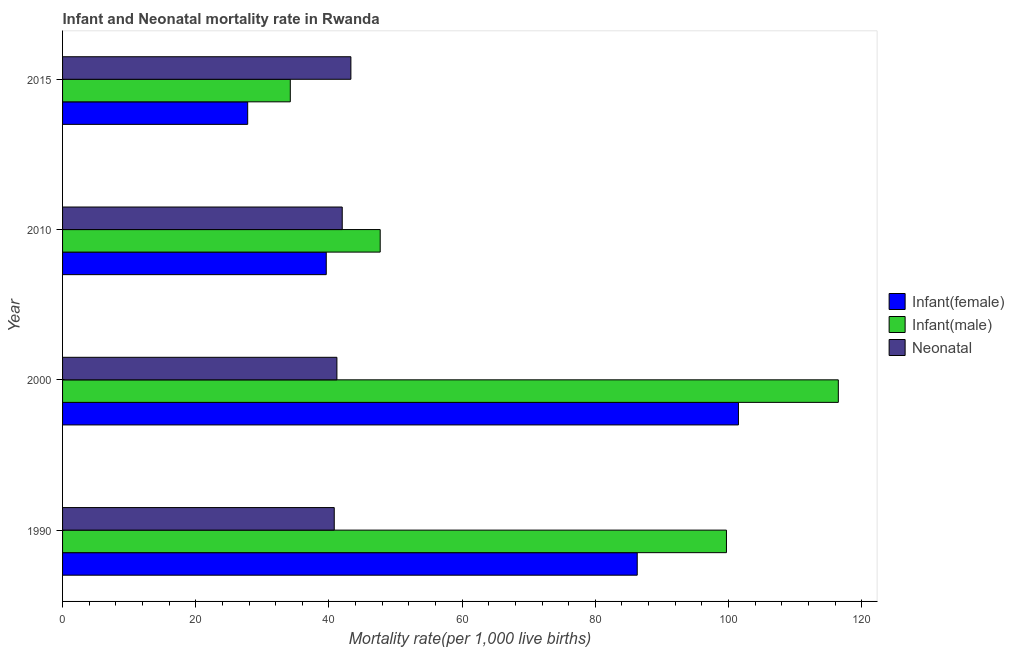How many groups of bars are there?
Your response must be concise. 4. How many bars are there on the 2nd tick from the bottom?
Your answer should be very brief. 3. What is the label of the 3rd group of bars from the top?
Provide a succinct answer. 2000. What is the infant mortality rate(male) in 2000?
Your answer should be very brief. 116.5. Across all years, what is the maximum infant mortality rate(female)?
Offer a very short reply. 101.5. Across all years, what is the minimum infant mortality rate(male)?
Offer a terse response. 34.2. In which year was the infant mortality rate(male) maximum?
Offer a very short reply. 2000. What is the total neonatal mortality rate in the graph?
Your answer should be very brief. 167.3. What is the difference between the infant mortality rate(male) in 2000 and the neonatal mortality rate in 2010?
Your answer should be very brief. 74.5. What is the average infant mortality rate(male) per year?
Offer a very short reply. 74.53. What is the ratio of the neonatal mortality rate in 1990 to that in 2015?
Your answer should be compact. 0.94. What is the difference between the highest and the second highest infant mortality rate(male)?
Provide a short and direct response. 16.8. What is the difference between the highest and the lowest infant mortality rate(male)?
Make the answer very short. 82.3. In how many years, is the neonatal mortality rate greater than the average neonatal mortality rate taken over all years?
Your answer should be very brief. 2. Is the sum of the infant mortality rate(male) in 1990 and 2015 greater than the maximum infant mortality rate(female) across all years?
Your answer should be very brief. Yes. What does the 3rd bar from the top in 2015 represents?
Make the answer very short. Infant(female). What does the 1st bar from the bottom in 1990 represents?
Keep it short and to the point. Infant(female). Does the graph contain any zero values?
Offer a terse response. No. Does the graph contain grids?
Offer a terse response. No. How are the legend labels stacked?
Make the answer very short. Vertical. What is the title of the graph?
Ensure brevity in your answer.  Infant and Neonatal mortality rate in Rwanda. What is the label or title of the X-axis?
Provide a short and direct response. Mortality rate(per 1,0 live births). What is the label or title of the Y-axis?
Provide a short and direct response. Year. What is the Mortality rate(per 1,000 live births) in Infant(female) in 1990?
Offer a very short reply. 86.3. What is the Mortality rate(per 1,000 live births) of Infant(male) in 1990?
Offer a terse response. 99.7. What is the Mortality rate(per 1,000 live births) in Neonatal  in 1990?
Make the answer very short. 40.8. What is the Mortality rate(per 1,000 live births) of Infant(female) in 2000?
Ensure brevity in your answer.  101.5. What is the Mortality rate(per 1,000 live births) of Infant(male) in 2000?
Your response must be concise. 116.5. What is the Mortality rate(per 1,000 live births) in Neonatal  in 2000?
Your response must be concise. 41.2. What is the Mortality rate(per 1,000 live births) in Infant(female) in 2010?
Keep it short and to the point. 39.6. What is the Mortality rate(per 1,000 live births) of Infant(male) in 2010?
Provide a succinct answer. 47.7. What is the Mortality rate(per 1,000 live births) of Neonatal  in 2010?
Your answer should be very brief. 42. What is the Mortality rate(per 1,000 live births) in Infant(female) in 2015?
Make the answer very short. 27.8. What is the Mortality rate(per 1,000 live births) in Infant(male) in 2015?
Make the answer very short. 34.2. What is the Mortality rate(per 1,000 live births) in Neonatal  in 2015?
Your answer should be compact. 43.3. Across all years, what is the maximum Mortality rate(per 1,000 live births) in Infant(female)?
Your answer should be very brief. 101.5. Across all years, what is the maximum Mortality rate(per 1,000 live births) in Infant(male)?
Provide a succinct answer. 116.5. Across all years, what is the maximum Mortality rate(per 1,000 live births) in Neonatal ?
Make the answer very short. 43.3. Across all years, what is the minimum Mortality rate(per 1,000 live births) of Infant(female)?
Your response must be concise. 27.8. Across all years, what is the minimum Mortality rate(per 1,000 live births) in Infant(male)?
Keep it short and to the point. 34.2. Across all years, what is the minimum Mortality rate(per 1,000 live births) of Neonatal ?
Your answer should be compact. 40.8. What is the total Mortality rate(per 1,000 live births) in Infant(female) in the graph?
Ensure brevity in your answer.  255.2. What is the total Mortality rate(per 1,000 live births) of Infant(male) in the graph?
Provide a succinct answer. 298.1. What is the total Mortality rate(per 1,000 live births) in Neonatal  in the graph?
Your answer should be compact. 167.3. What is the difference between the Mortality rate(per 1,000 live births) of Infant(female) in 1990 and that in 2000?
Your response must be concise. -15.2. What is the difference between the Mortality rate(per 1,000 live births) of Infant(male) in 1990 and that in 2000?
Offer a very short reply. -16.8. What is the difference between the Mortality rate(per 1,000 live births) of Infant(female) in 1990 and that in 2010?
Provide a short and direct response. 46.7. What is the difference between the Mortality rate(per 1,000 live births) of Infant(female) in 1990 and that in 2015?
Keep it short and to the point. 58.5. What is the difference between the Mortality rate(per 1,000 live births) of Infant(male) in 1990 and that in 2015?
Keep it short and to the point. 65.5. What is the difference between the Mortality rate(per 1,000 live births) of Neonatal  in 1990 and that in 2015?
Offer a very short reply. -2.5. What is the difference between the Mortality rate(per 1,000 live births) of Infant(female) in 2000 and that in 2010?
Offer a very short reply. 61.9. What is the difference between the Mortality rate(per 1,000 live births) in Infant(male) in 2000 and that in 2010?
Offer a terse response. 68.8. What is the difference between the Mortality rate(per 1,000 live births) in Infant(female) in 2000 and that in 2015?
Provide a short and direct response. 73.7. What is the difference between the Mortality rate(per 1,000 live births) in Infant(male) in 2000 and that in 2015?
Your answer should be compact. 82.3. What is the difference between the Mortality rate(per 1,000 live births) in Infant(female) in 2010 and that in 2015?
Give a very brief answer. 11.8. What is the difference between the Mortality rate(per 1,000 live births) of Infant(female) in 1990 and the Mortality rate(per 1,000 live births) of Infant(male) in 2000?
Your answer should be very brief. -30.2. What is the difference between the Mortality rate(per 1,000 live births) of Infant(female) in 1990 and the Mortality rate(per 1,000 live births) of Neonatal  in 2000?
Your answer should be compact. 45.1. What is the difference between the Mortality rate(per 1,000 live births) in Infant(male) in 1990 and the Mortality rate(per 1,000 live births) in Neonatal  in 2000?
Ensure brevity in your answer.  58.5. What is the difference between the Mortality rate(per 1,000 live births) in Infant(female) in 1990 and the Mortality rate(per 1,000 live births) in Infant(male) in 2010?
Offer a terse response. 38.6. What is the difference between the Mortality rate(per 1,000 live births) in Infant(female) in 1990 and the Mortality rate(per 1,000 live births) in Neonatal  in 2010?
Offer a terse response. 44.3. What is the difference between the Mortality rate(per 1,000 live births) of Infant(male) in 1990 and the Mortality rate(per 1,000 live births) of Neonatal  in 2010?
Make the answer very short. 57.7. What is the difference between the Mortality rate(per 1,000 live births) of Infant(female) in 1990 and the Mortality rate(per 1,000 live births) of Infant(male) in 2015?
Give a very brief answer. 52.1. What is the difference between the Mortality rate(per 1,000 live births) of Infant(male) in 1990 and the Mortality rate(per 1,000 live births) of Neonatal  in 2015?
Your response must be concise. 56.4. What is the difference between the Mortality rate(per 1,000 live births) of Infant(female) in 2000 and the Mortality rate(per 1,000 live births) of Infant(male) in 2010?
Keep it short and to the point. 53.8. What is the difference between the Mortality rate(per 1,000 live births) of Infant(female) in 2000 and the Mortality rate(per 1,000 live births) of Neonatal  in 2010?
Offer a very short reply. 59.5. What is the difference between the Mortality rate(per 1,000 live births) of Infant(male) in 2000 and the Mortality rate(per 1,000 live births) of Neonatal  in 2010?
Provide a succinct answer. 74.5. What is the difference between the Mortality rate(per 1,000 live births) of Infant(female) in 2000 and the Mortality rate(per 1,000 live births) of Infant(male) in 2015?
Your answer should be compact. 67.3. What is the difference between the Mortality rate(per 1,000 live births) of Infant(female) in 2000 and the Mortality rate(per 1,000 live births) of Neonatal  in 2015?
Provide a short and direct response. 58.2. What is the difference between the Mortality rate(per 1,000 live births) of Infant(male) in 2000 and the Mortality rate(per 1,000 live births) of Neonatal  in 2015?
Offer a very short reply. 73.2. What is the difference between the Mortality rate(per 1,000 live births) of Infant(female) in 2010 and the Mortality rate(per 1,000 live births) of Neonatal  in 2015?
Make the answer very short. -3.7. What is the difference between the Mortality rate(per 1,000 live births) in Infant(male) in 2010 and the Mortality rate(per 1,000 live births) in Neonatal  in 2015?
Make the answer very short. 4.4. What is the average Mortality rate(per 1,000 live births) in Infant(female) per year?
Give a very brief answer. 63.8. What is the average Mortality rate(per 1,000 live births) of Infant(male) per year?
Ensure brevity in your answer.  74.53. What is the average Mortality rate(per 1,000 live births) in Neonatal  per year?
Your response must be concise. 41.83. In the year 1990, what is the difference between the Mortality rate(per 1,000 live births) in Infant(female) and Mortality rate(per 1,000 live births) in Infant(male)?
Provide a short and direct response. -13.4. In the year 1990, what is the difference between the Mortality rate(per 1,000 live births) in Infant(female) and Mortality rate(per 1,000 live births) in Neonatal ?
Keep it short and to the point. 45.5. In the year 1990, what is the difference between the Mortality rate(per 1,000 live births) in Infant(male) and Mortality rate(per 1,000 live births) in Neonatal ?
Your answer should be compact. 58.9. In the year 2000, what is the difference between the Mortality rate(per 1,000 live births) of Infant(female) and Mortality rate(per 1,000 live births) of Neonatal ?
Your response must be concise. 60.3. In the year 2000, what is the difference between the Mortality rate(per 1,000 live births) in Infant(male) and Mortality rate(per 1,000 live births) in Neonatal ?
Provide a short and direct response. 75.3. In the year 2010, what is the difference between the Mortality rate(per 1,000 live births) in Infant(female) and Mortality rate(per 1,000 live births) in Infant(male)?
Offer a terse response. -8.1. In the year 2010, what is the difference between the Mortality rate(per 1,000 live births) of Infant(male) and Mortality rate(per 1,000 live births) of Neonatal ?
Your answer should be very brief. 5.7. In the year 2015, what is the difference between the Mortality rate(per 1,000 live births) in Infant(female) and Mortality rate(per 1,000 live births) in Neonatal ?
Ensure brevity in your answer.  -15.5. What is the ratio of the Mortality rate(per 1,000 live births) in Infant(female) in 1990 to that in 2000?
Your answer should be compact. 0.85. What is the ratio of the Mortality rate(per 1,000 live births) of Infant(male) in 1990 to that in 2000?
Offer a terse response. 0.86. What is the ratio of the Mortality rate(per 1,000 live births) in Neonatal  in 1990 to that in 2000?
Your response must be concise. 0.99. What is the ratio of the Mortality rate(per 1,000 live births) in Infant(female) in 1990 to that in 2010?
Make the answer very short. 2.18. What is the ratio of the Mortality rate(per 1,000 live births) in Infant(male) in 1990 to that in 2010?
Your answer should be very brief. 2.09. What is the ratio of the Mortality rate(per 1,000 live births) of Neonatal  in 1990 to that in 2010?
Offer a very short reply. 0.97. What is the ratio of the Mortality rate(per 1,000 live births) of Infant(female) in 1990 to that in 2015?
Make the answer very short. 3.1. What is the ratio of the Mortality rate(per 1,000 live births) of Infant(male) in 1990 to that in 2015?
Provide a succinct answer. 2.92. What is the ratio of the Mortality rate(per 1,000 live births) of Neonatal  in 1990 to that in 2015?
Ensure brevity in your answer.  0.94. What is the ratio of the Mortality rate(per 1,000 live births) in Infant(female) in 2000 to that in 2010?
Provide a succinct answer. 2.56. What is the ratio of the Mortality rate(per 1,000 live births) in Infant(male) in 2000 to that in 2010?
Provide a short and direct response. 2.44. What is the ratio of the Mortality rate(per 1,000 live births) of Infant(female) in 2000 to that in 2015?
Offer a very short reply. 3.65. What is the ratio of the Mortality rate(per 1,000 live births) in Infant(male) in 2000 to that in 2015?
Ensure brevity in your answer.  3.41. What is the ratio of the Mortality rate(per 1,000 live births) in Neonatal  in 2000 to that in 2015?
Your answer should be compact. 0.95. What is the ratio of the Mortality rate(per 1,000 live births) in Infant(female) in 2010 to that in 2015?
Your answer should be compact. 1.42. What is the ratio of the Mortality rate(per 1,000 live births) of Infant(male) in 2010 to that in 2015?
Offer a terse response. 1.39. What is the ratio of the Mortality rate(per 1,000 live births) of Neonatal  in 2010 to that in 2015?
Keep it short and to the point. 0.97. What is the difference between the highest and the second highest Mortality rate(per 1,000 live births) in Infant(male)?
Your answer should be compact. 16.8. What is the difference between the highest and the lowest Mortality rate(per 1,000 live births) of Infant(female)?
Give a very brief answer. 73.7. What is the difference between the highest and the lowest Mortality rate(per 1,000 live births) in Infant(male)?
Your response must be concise. 82.3. 